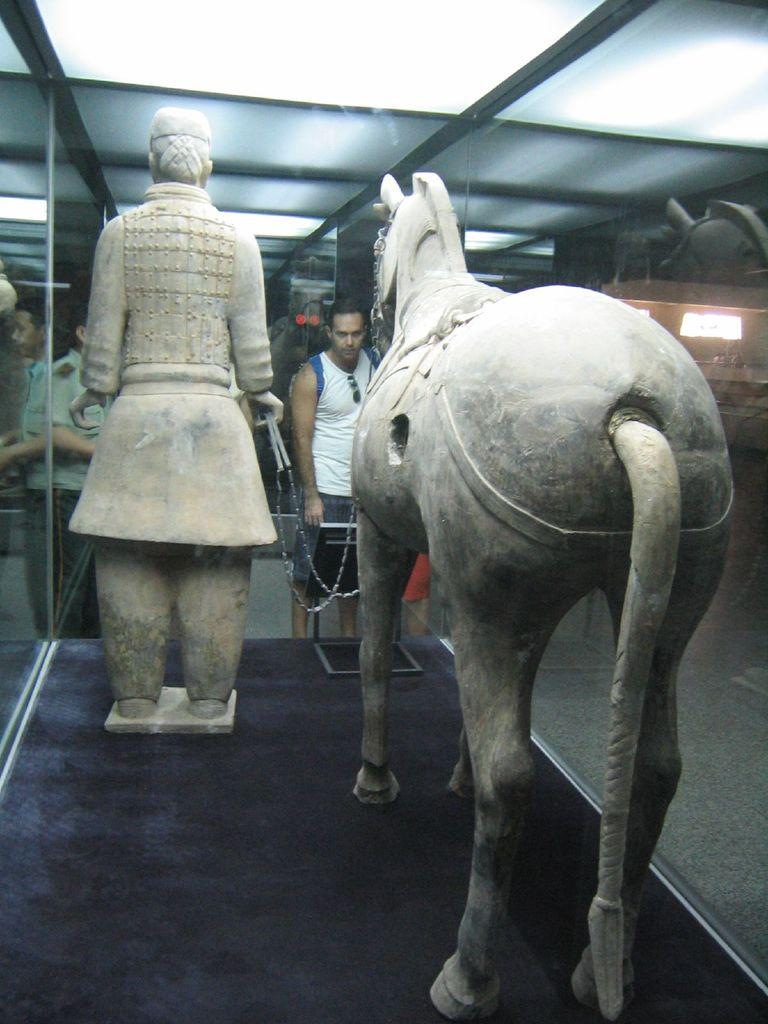What is inside the glass container in the image? There are statues inside a glass container in the image. What can be seen on the floor in the image? There are people standing on the floor in the image. What is visible above the people in the image? There is a roof visible in the image. What type of lighting is present in the image? There are ceiling lights on the roof in the image. What type of guitar can be seen hanging from the ceiling in the image? There is no guitar present in the image; the only objects mentioned are statues inside a glass container, people standing on the floor, a roof, and ceiling lights. 